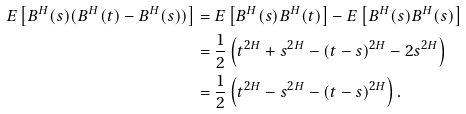<formula> <loc_0><loc_0><loc_500><loc_500>E \left [ B ^ { H } ( s ) ( B ^ { H } ( t ) - B ^ { H } ( s ) ) \right ] & = E \left [ B ^ { H } ( s ) B ^ { H } ( t ) \right ] - E \left [ B ^ { H } ( s ) B ^ { H } ( s ) \right ] \\ & = \frac { 1 } { 2 } \left ( t ^ { 2 H } + s ^ { 2 H } - ( t - s ) ^ { 2 H } - 2 s ^ { 2 H } \right ) \\ & = \frac { 1 } { 2 } \left ( t ^ { 2 H } - s ^ { 2 H } - ( t - s ) ^ { 2 H } \right ) .</formula> 